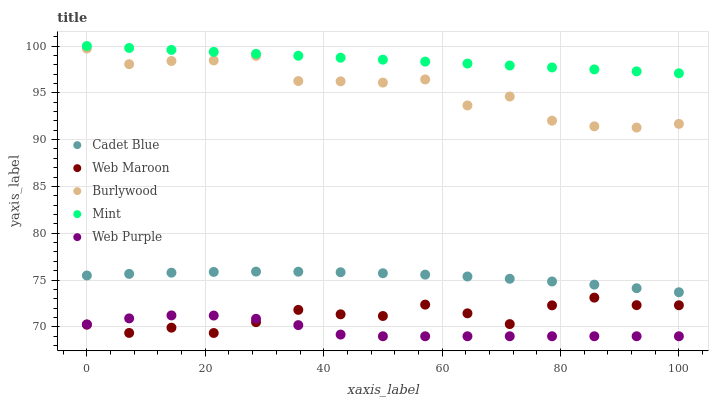Does Web Purple have the minimum area under the curve?
Answer yes or no. Yes. Does Mint have the maximum area under the curve?
Answer yes or no. Yes. Does Mint have the minimum area under the curve?
Answer yes or no. No. Does Web Purple have the maximum area under the curve?
Answer yes or no. No. Is Mint the smoothest?
Answer yes or no. Yes. Is Burlywood the roughest?
Answer yes or no. Yes. Is Web Purple the smoothest?
Answer yes or no. No. Is Web Purple the roughest?
Answer yes or no. No. Does Web Purple have the lowest value?
Answer yes or no. Yes. Does Mint have the lowest value?
Answer yes or no. No. Does Mint have the highest value?
Answer yes or no. Yes. Does Web Purple have the highest value?
Answer yes or no. No. Is Burlywood less than Mint?
Answer yes or no. Yes. Is Cadet Blue greater than Web Maroon?
Answer yes or no. Yes. Does Web Purple intersect Web Maroon?
Answer yes or no. Yes. Is Web Purple less than Web Maroon?
Answer yes or no. No. Is Web Purple greater than Web Maroon?
Answer yes or no. No. Does Burlywood intersect Mint?
Answer yes or no. No. 